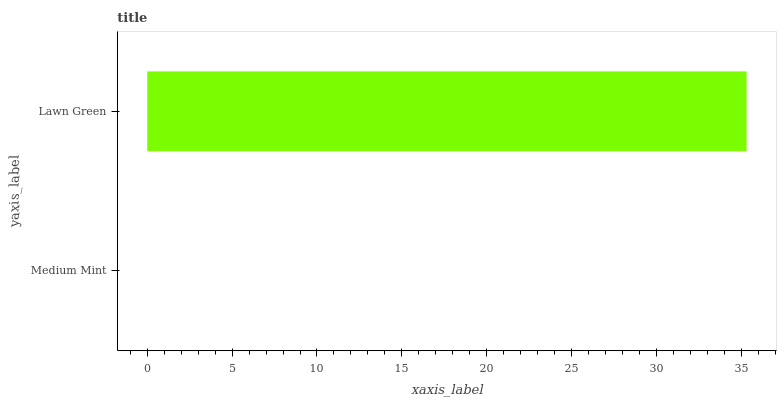Is Medium Mint the minimum?
Answer yes or no. Yes. Is Lawn Green the maximum?
Answer yes or no. Yes. Is Lawn Green the minimum?
Answer yes or no. No. Is Lawn Green greater than Medium Mint?
Answer yes or no. Yes. Is Medium Mint less than Lawn Green?
Answer yes or no. Yes. Is Medium Mint greater than Lawn Green?
Answer yes or no. No. Is Lawn Green less than Medium Mint?
Answer yes or no. No. Is Lawn Green the high median?
Answer yes or no. Yes. Is Medium Mint the low median?
Answer yes or no. Yes. Is Medium Mint the high median?
Answer yes or no. No. Is Lawn Green the low median?
Answer yes or no. No. 